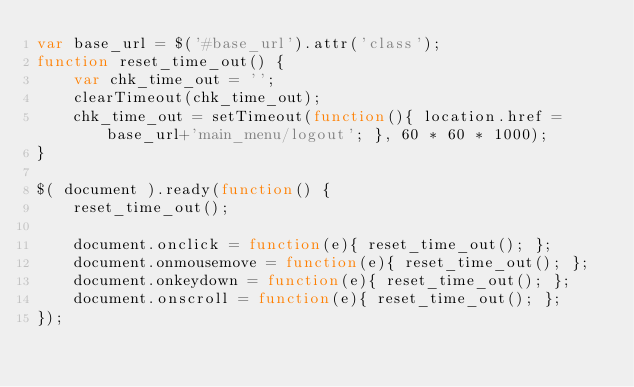Convert code to text. <code><loc_0><loc_0><loc_500><loc_500><_JavaScript_>var base_url = $('#base_url').attr('class');
function reset_time_out() {
	var chk_time_out = '';
	clearTimeout(chk_time_out);
	chk_time_out = setTimeout(function(){ location.href = base_url+'main_menu/logout'; }, 60 * 60 * 1000);
}

$( document ).ready(function() {
	reset_time_out();

	document.onclick = function(e){ reset_time_out(); };
	document.onmousemove = function(e){ reset_time_out(); };
	document.onkeydown = function(e){ reset_time_out(); };
	document.onscroll = function(e){ reset_time_out(); };
});	</code> 